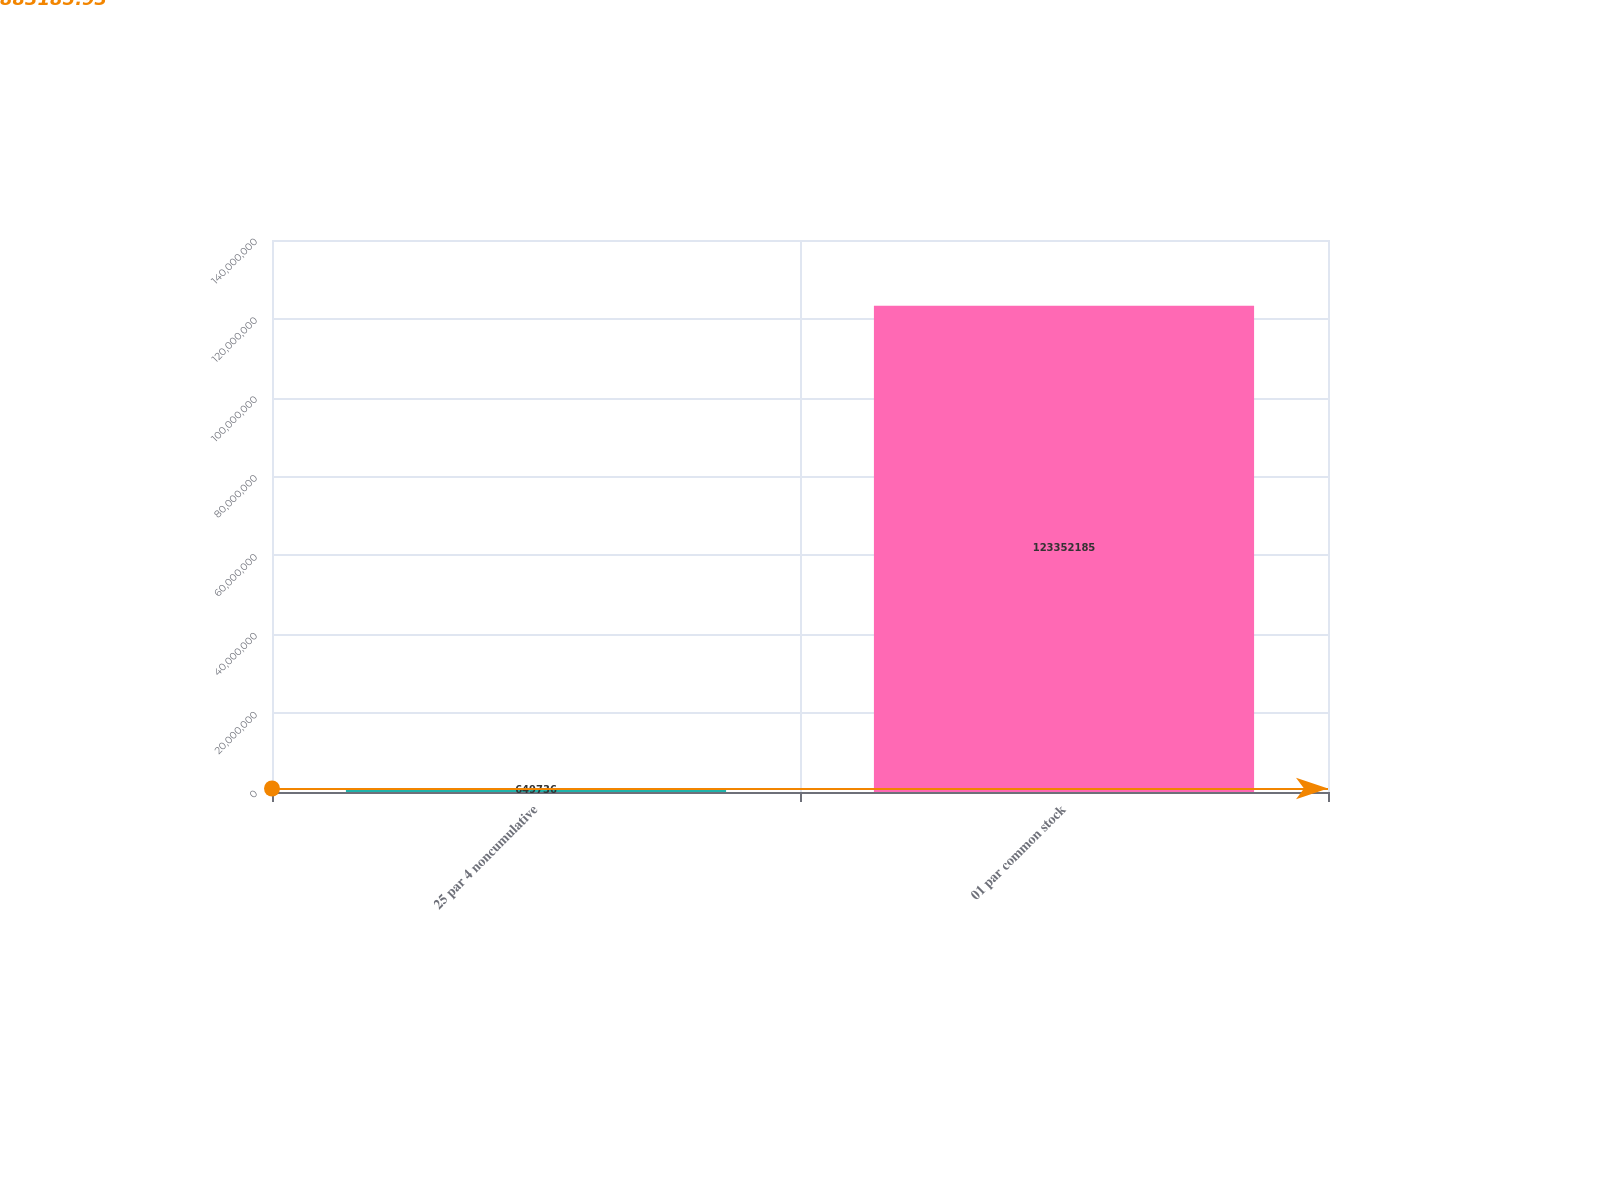Convert chart. <chart><loc_0><loc_0><loc_500><loc_500><bar_chart><fcel>25 par 4 noncumulative<fcel>01 par common stock<nl><fcel>649736<fcel>1.23352e+08<nl></chart> 